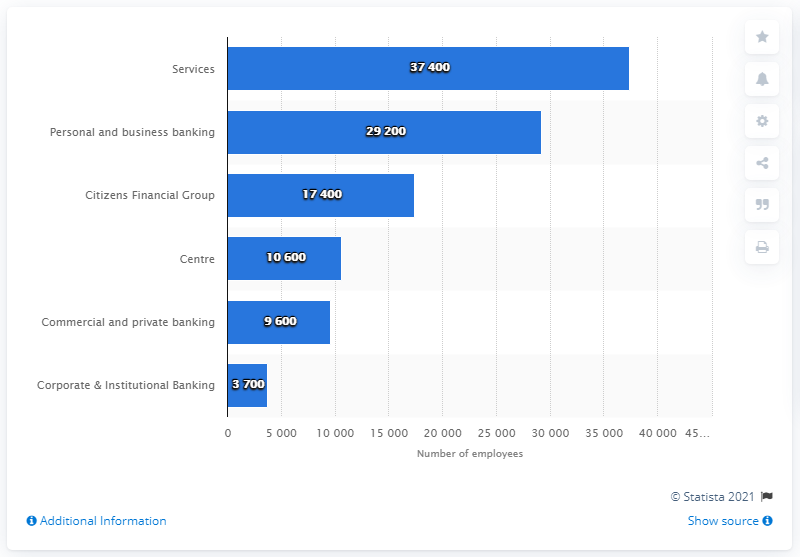Specify some key components in this picture. In 2014, approximately 37,400 individuals were employed in the services division of the Royal Bank of Scotland (RBS). In 2014, the personal and business banking division of RBS employed 29,200 people. 